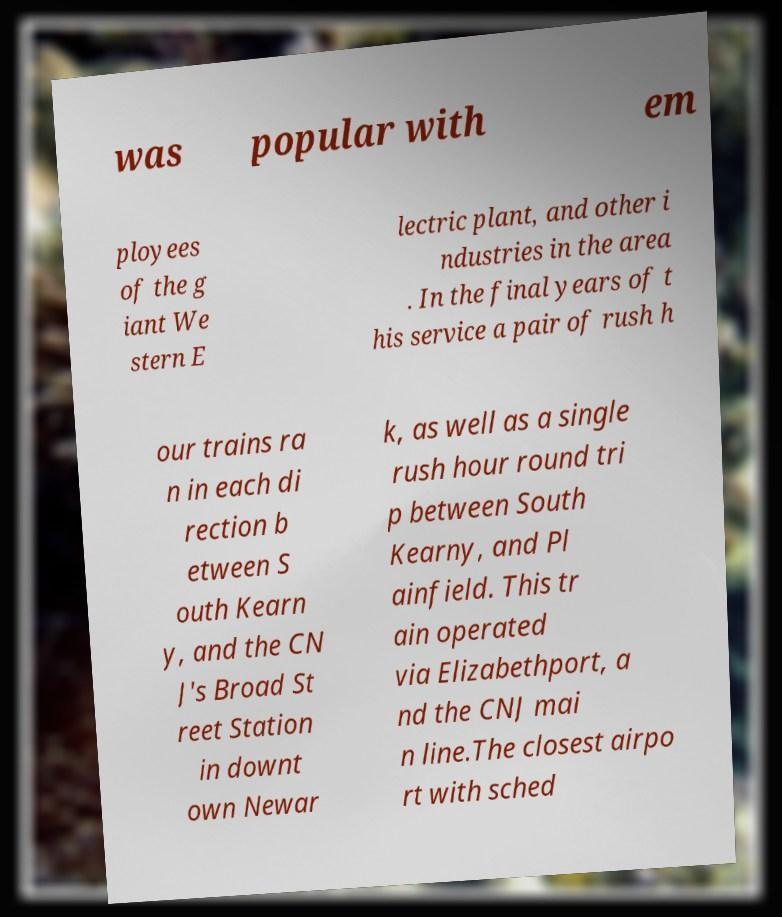For documentation purposes, I need the text within this image transcribed. Could you provide that? was popular with em ployees of the g iant We stern E lectric plant, and other i ndustries in the area . In the final years of t his service a pair of rush h our trains ra n in each di rection b etween S outh Kearn y, and the CN J's Broad St reet Station in downt own Newar k, as well as a single rush hour round tri p between South Kearny, and Pl ainfield. This tr ain operated via Elizabethport, a nd the CNJ mai n line.The closest airpo rt with sched 